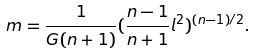Convert formula to latex. <formula><loc_0><loc_0><loc_500><loc_500>m = \frac { 1 } { G ( n + 1 ) } ( \frac { n - 1 } { n + 1 } l ^ { 2 } ) ^ { ( n - 1 ) / 2 } .</formula> 